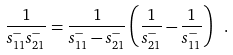<formula> <loc_0><loc_0><loc_500><loc_500>\frac { 1 } { s _ { 1 1 } ^ { - } s _ { 2 1 } ^ { - } } = \frac { 1 } { s _ { 1 1 } ^ { - } - s _ { 2 1 } ^ { - } } \left ( \frac { 1 } { s _ { 2 1 } ^ { - } } - \frac { 1 } { s _ { 1 1 } ^ { - } } \right ) \ .</formula> 